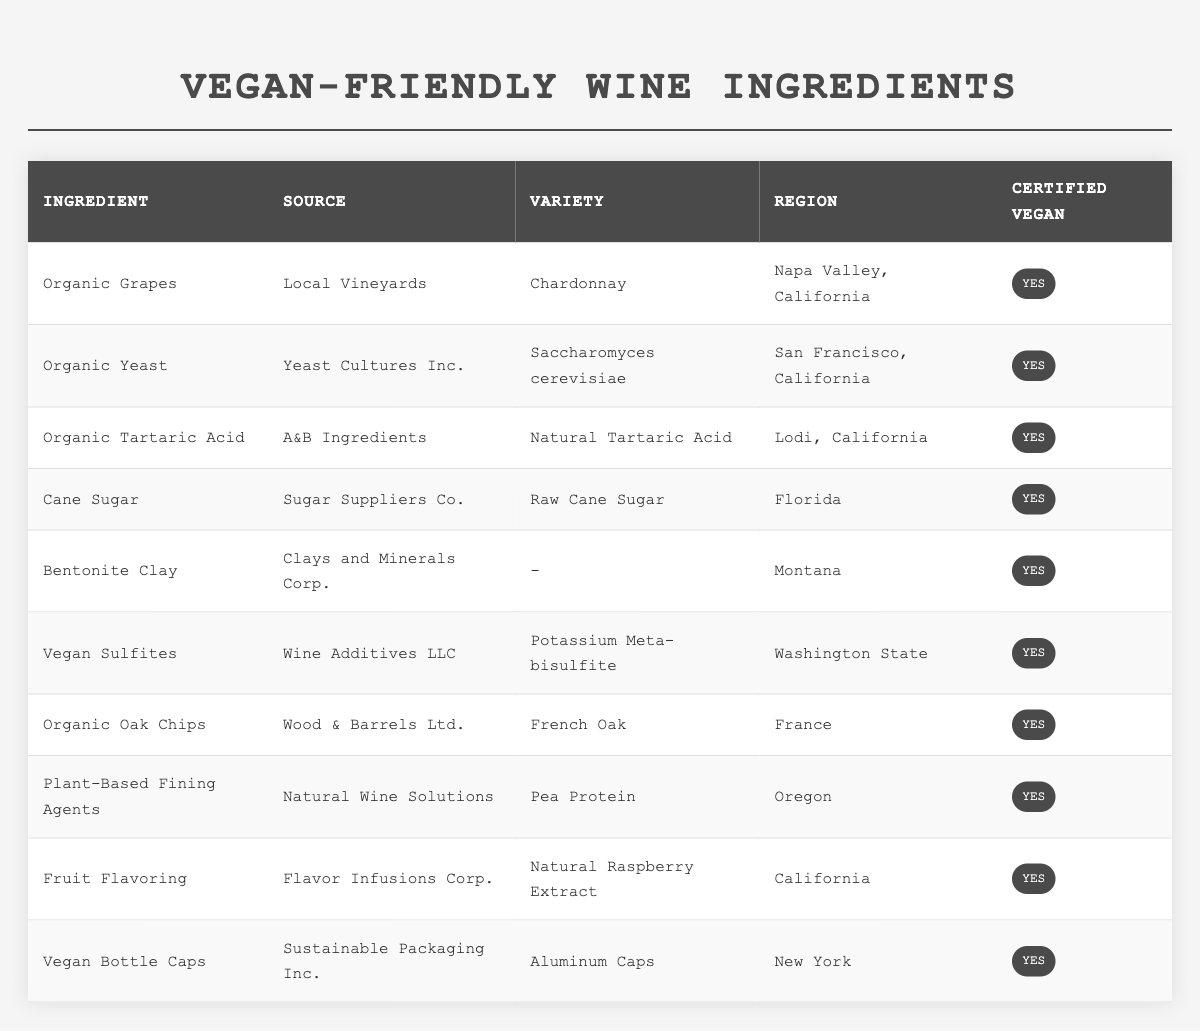What is the region for "Organic Grapes"? The table lists "Organic Grapes" under the ingredient column. Looking at the same row, the region indicated for "Organic Grapes" is "Napa Valley, California."
Answer: Napa Valley, California How many ingredients are sourced from California? By counting the entries in the region column that indicate California, we find a total of 4 ingredients: Organic Grapes, Organic Yeast, Organic Tartaric Acid, and Fruit Flavoring.
Answer: 4 Is "Bentonite Clay" certified vegan? The table shows "Bentonite Clay" in one of the rows and states that it is certified vegan, as indicated by the "Yes" in the certified vegan column.
Answer: Yes What variety of yeast is used in the production? The table specifies the variety of yeast under the ingredient "Organic Yeast" as "Saccharomyces cerevisiae."
Answer: Saccharomyces cerevisiae Which ingredient sourced from France is certified vegan? Referring to the table, we see "Organic Oak Chips" sourced from France, which is marked as certified vegan in the respective column.
Answer: Organic Oak Chips Are there any ingredients from states outside of California? Yes, examining the table shows ingredients sourced from Florida, Montana, Washington State, and New York, indicating there are ingredients sourced from outside of California.
Answer: Yes What is the total number of ingredients listed in the table? The table lists a total of 10 ingredients, as we can count each row in the body of the table.
Answer: 10 Which ingredient has the source "Wine Additives LLC"? Looking at the table, we find that "Vegan Sulfites" is listed under the ingredient that has the source "Wine Additives LLC."
Answer: Vegan Sulfites What are the vegan-certified ingredients sourced from Oregon? The table shows that "Plant-Based Fining Agents" is the only ingredient listed from Oregon, confirmed as certified vegan.
Answer: Plant-Based Fining Agents What is the common characteristic shared by all listed ingredients? All listed ingredients are certified vegan, a detail confirmed by the "Yes" marked in the certified vegan column for each entry.
Answer: Certified vegan 